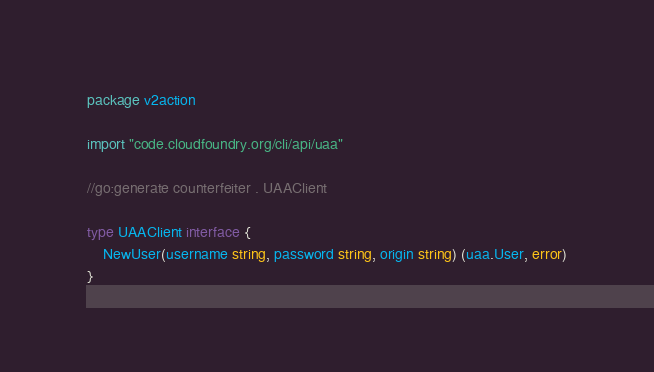<code> <loc_0><loc_0><loc_500><loc_500><_Go_>package v2action

import "code.cloudfoundry.org/cli/api/uaa"

//go:generate counterfeiter . UAAClient

type UAAClient interface {
	NewUser(username string, password string, origin string) (uaa.User, error)
}
</code> 